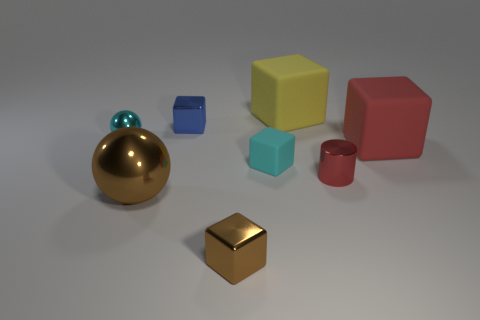Subtract all large matte cubes. How many cubes are left? 3 Subtract all red blocks. How many blocks are left? 4 Add 1 big spheres. How many objects exist? 9 Subtract all yellow blocks. Subtract all brown cylinders. How many blocks are left? 4 Subtract all cylinders. How many objects are left? 7 Add 5 large blocks. How many large blocks exist? 7 Subtract 1 brown blocks. How many objects are left? 7 Subtract all large red balls. Subtract all brown shiny cubes. How many objects are left? 7 Add 6 tiny red cylinders. How many tiny red cylinders are left? 7 